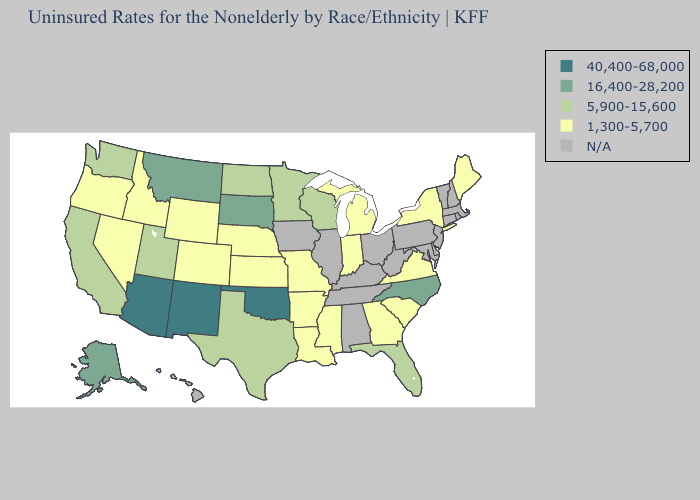What is the value of Kentucky?
Quick response, please. N/A. What is the lowest value in the USA?
Answer briefly. 1,300-5,700. What is the lowest value in the USA?
Short answer required. 1,300-5,700. Does the first symbol in the legend represent the smallest category?
Keep it brief. No. Name the states that have a value in the range 40,400-68,000?
Be succinct. Arizona, New Mexico, Oklahoma. What is the value of Pennsylvania?
Be succinct. N/A. Does New Mexico have the highest value in the USA?
Quick response, please. Yes. What is the lowest value in the MidWest?
Short answer required. 1,300-5,700. What is the value of California?
Quick response, please. 5,900-15,600. Does the map have missing data?
Give a very brief answer. Yes. How many symbols are there in the legend?
Keep it brief. 5. 